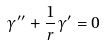Convert formula to latex. <formula><loc_0><loc_0><loc_500><loc_500>\gamma ^ { \prime \prime } + \frac { 1 } { r } \gamma ^ { \prime } = 0</formula> 